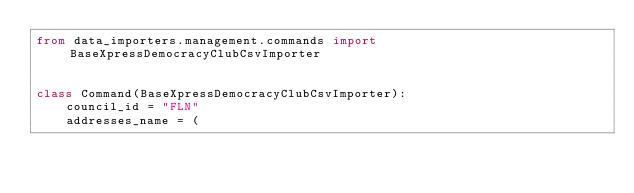Convert code to text. <code><loc_0><loc_0><loc_500><loc_500><_Python_>from data_importers.management.commands import BaseXpressDemocracyClubCsvImporter


class Command(BaseXpressDemocracyClubCsvImporter):
    council_id = "FLN"
    addresses_name = (</code> 